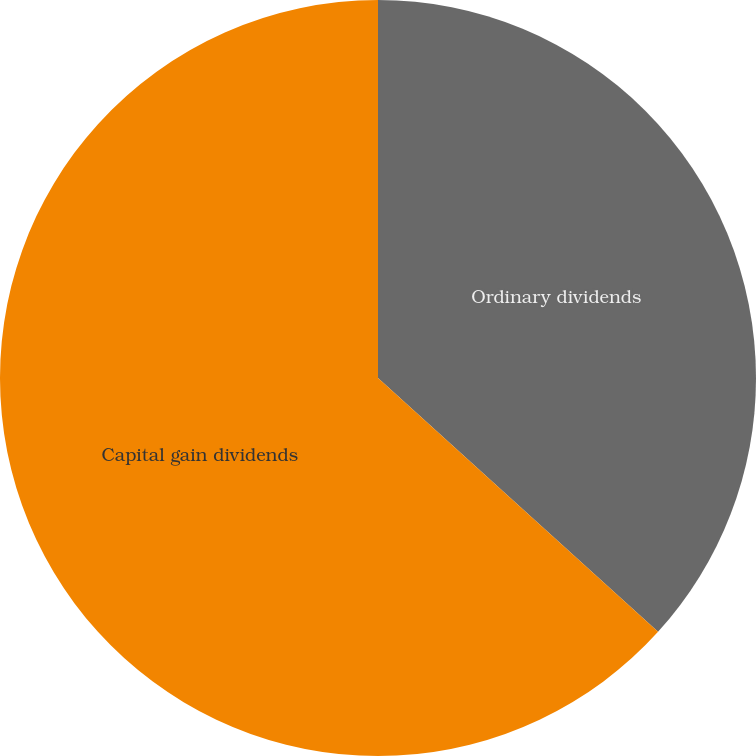Convert chart. <chart><loc_0><loc_0><loc_500><loc_500><pie_chart><fcel>Ordinary dividends<fcel>Capital gain dividends<nl><fcel>36.72%<fcel>63.28%<nl></chart> 